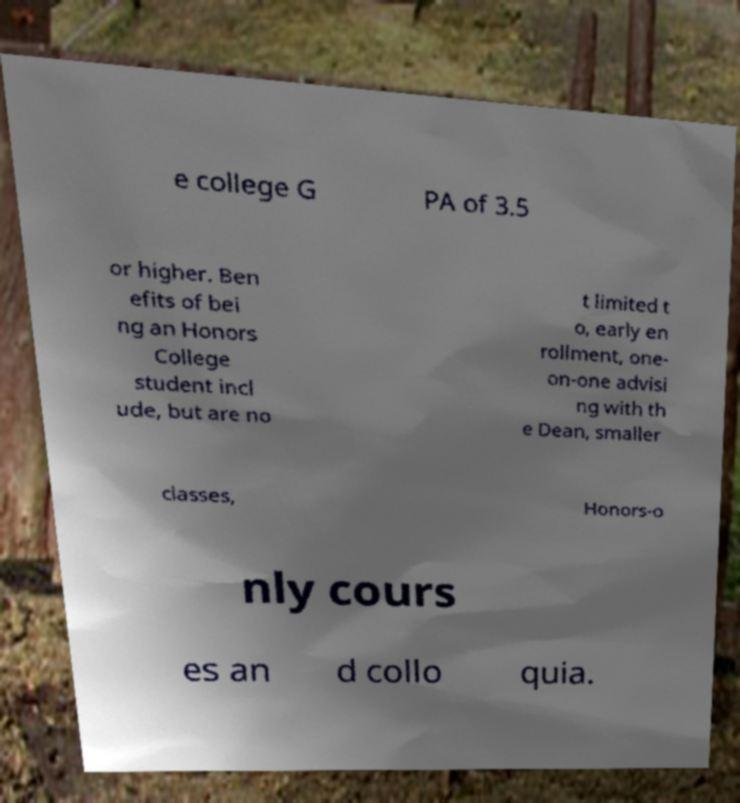For documentation purposes, I need the text within this image transcribed. Could you provide that? e college G PA of 3.5 or higher. Ben efits of bei ng an Honors College student incl ude, but are no t limited t o, early en rollment, one- on-one advisi ng with th e Dean, smaller classes, Honors-o nly cours es an d collo quia. 